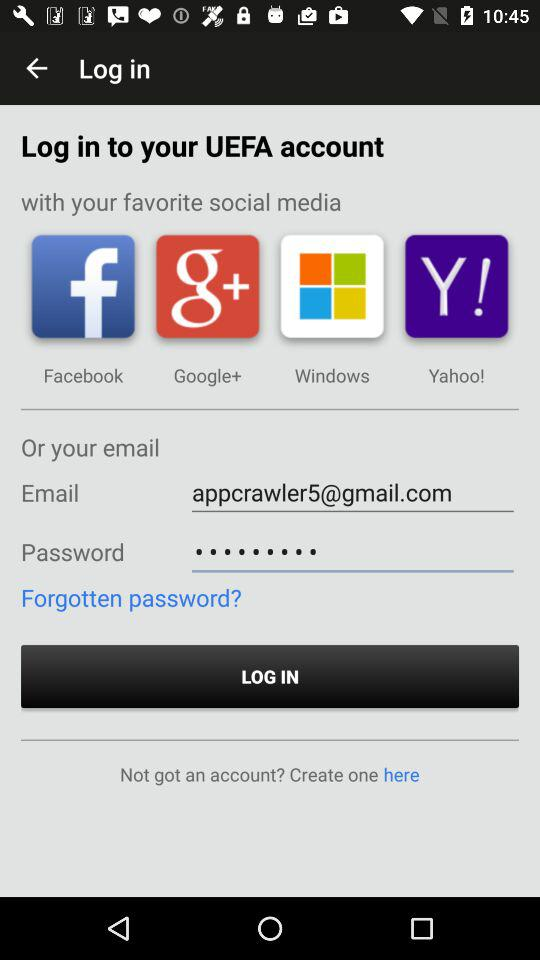What is the email address? The email address is appcrawler5@gmail.com. 